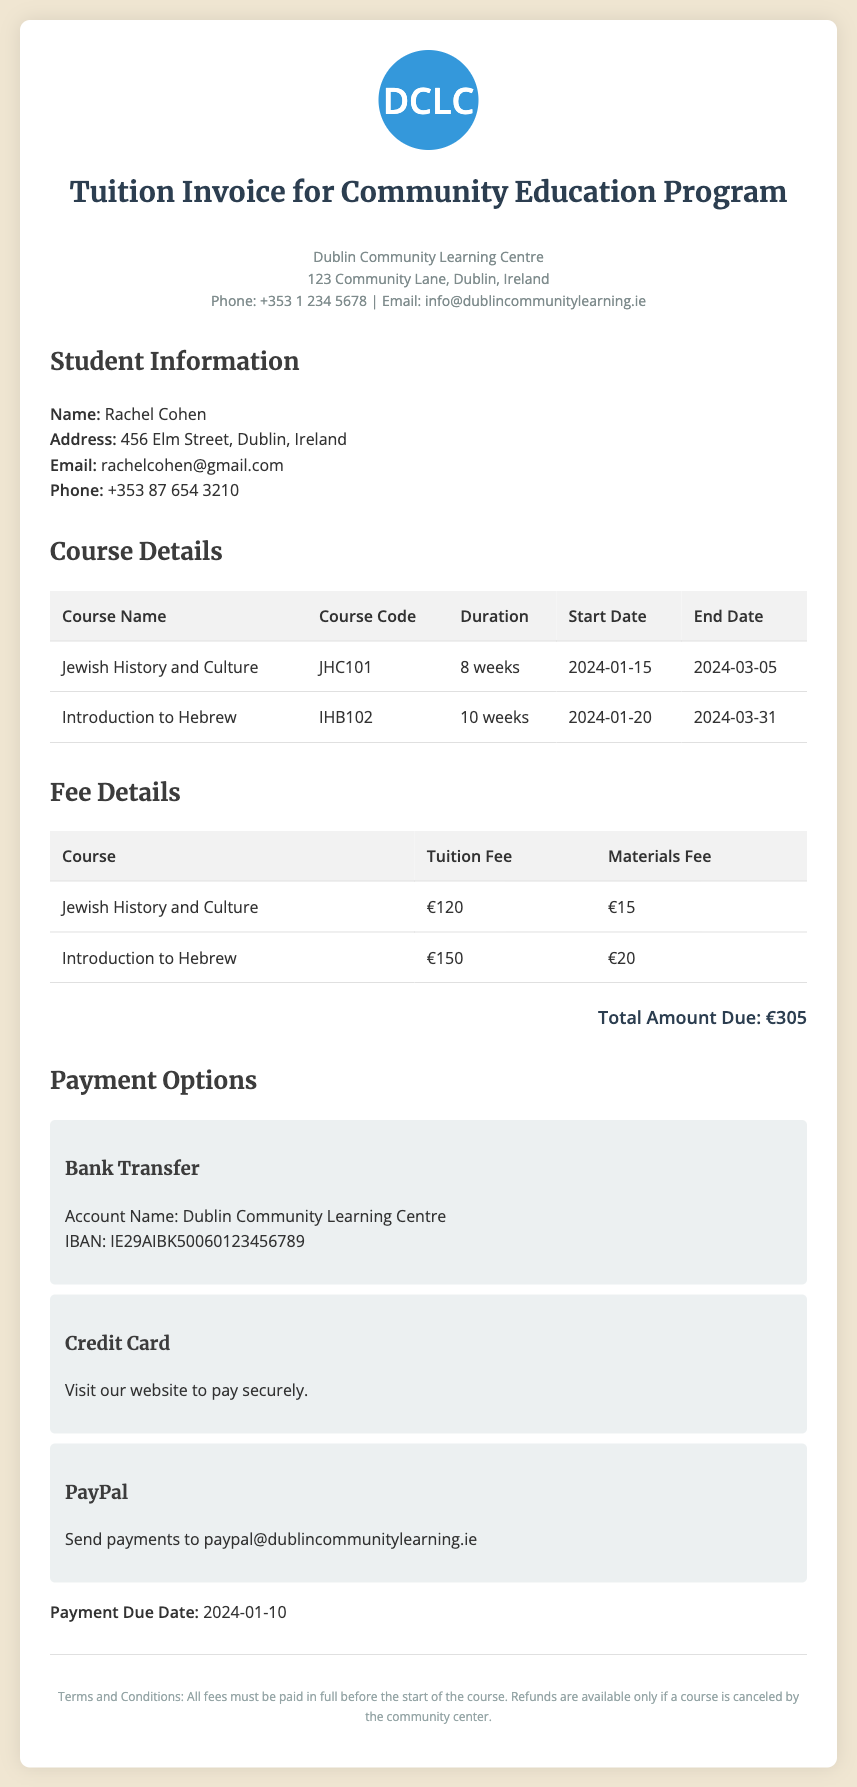What is the name of the student? The student's name is clearly stated in the document under "Student Information."
Answer: Rachel Cohen What is the total amount due? The total amount due is calculated and listed in the fee details section of the document.
Answer: €305 What is the duration of the "Jewish History and Culture" course? The duration is mentioned in the course details table for the specific course.
Answer: 8 weeks When is the payment due date? The payment due date is specified in the payment options section of the document.
Answer: 2024-01-10 What are the payment options available? The document lists different methods of payment available to the student in the payment options section.
Answer: Bank Transfer, Credit Card, PayPal How much is the materials fee for "Introduction to Hebrew"? The materials fee is detailed in the fee details section of the document for that specific course.
Answer: €20 What is the email address for payment inquiries? The email address can be found in the contact info area of the invoice.
Answer: info@dublincommunitylearning.ie What will happen if the course is canceled? The terms section explains the terms related to refunds in case of cancellations.
Answer: Refunds are available only if a course is canceled by the community center 